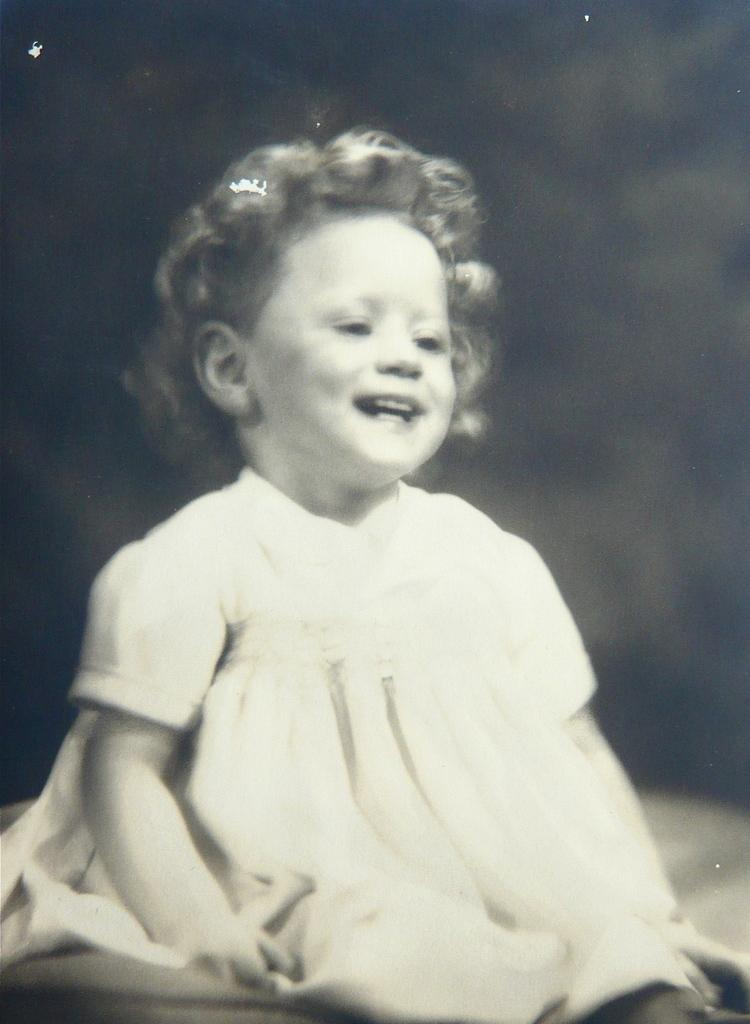Who is the main subject in the picture? There is a girl in the picture. What is the girl doing in the image? The girl is sitting. What expression does the girl have in the image? The girl is smiling. Can you describe the background of the image? The background of the image is blurred. What type of duck can be seen interacting with the girl in the image? There is no duck present in the image; it only features a girl sitting and smiling. How many grandmothers are visible in the image? There are no grandmothers present in the image; it only features a girl sitting and smiling. 